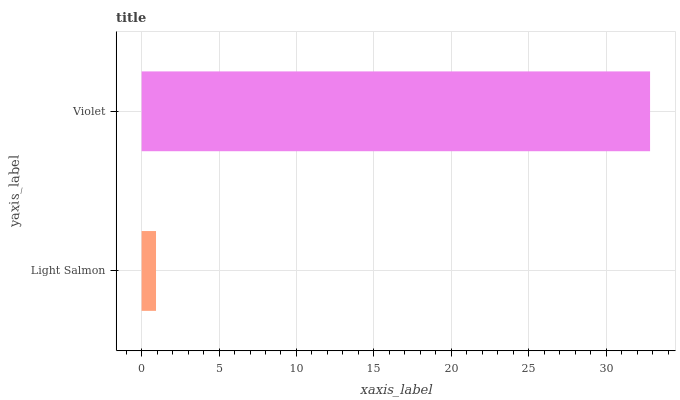Is Light Salmon the minimum?
Answer yes or no. Yes. Is Violet the maximum?
Answer yes or no. Yes. Is Violet the minimum?
Answer yes or no. No. Is Violet greater than Light Salmon?
Answer yes or no. Yes. Is Light Salmon less than Violet?
Answer yes or no. Yes. Is Light Salmon greater than Violet?
Answer yes or no. No. Is Violet less than Light Salmon?
Answer yes or no. No. Is Violet the high median?
Answer yes or no. Yes. Is Light Salmon the low median?
Answer yes or no. Yes. Is Light Salmon the high median?
Answer yes or no. No. Is Violet the low median?
Answer yes or no. No. 